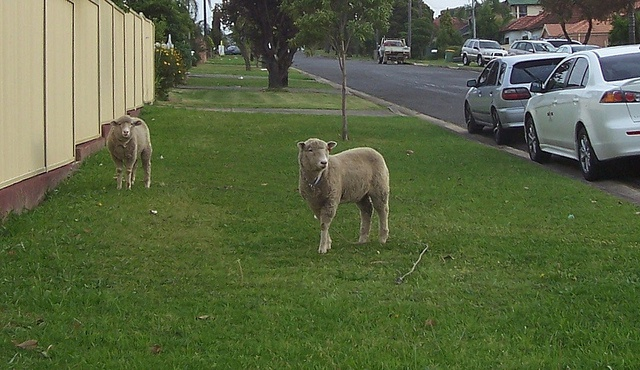Describe the objects in this image and their specific colors. I can see car in tan, darkgray, gray, black, and lightgray tones, sheep in tan, gray, darkgreen, and black tones, car in tan, gray, black, lightgray, and darkgray tones, sheep in tan, gray, darkgreen, and darkgray tones, and car in tan, gray, darkgray, black, and lightgray tones in this image. 